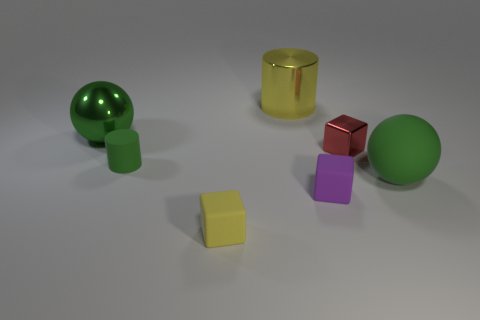What size is the thing behind the big green thing that is to the left of the green thing that is to the right of the tiny green object?
Keep it short and to the point. Large. Is the material of the tiny red thing the same as the large green ball in front of the small shiny cube?
Provide a short and direct response. No. Is the shape of the yellow metal object the same as the small metallic object?
Make the answer very short. No. What number of other things are there of the same material as the tiny cylinder
Your answer should be compact. 3. What number of big matte objects have the same shape as the red metallic object?
Give a very brief answer. 0. What is the color of the thing that is both behind the small rubber cylinder and in front of the big green metal sphere?
Your response must be concise. Red. How many cylinders are there?
Offer a very short reply. 2. Do the green cylinder and the yellow cylinder have the same size?
Your response must be concise. No. Are there any small metal objects of the same color as the large matte ball?
Offer a terse response. No. Is the shape of the green thing on the right side of the tiny yellow thing the same as  the small green rubber thing?
Your response must be concise. No. 